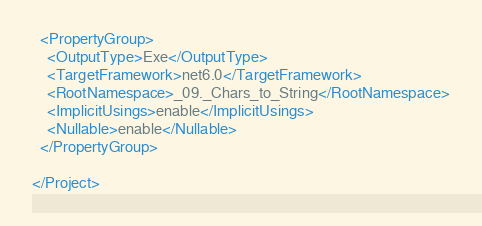<code> <loc_0><loc_0><loc_500><loc_500><_XML_>
  <PropertyGroup>
    <OutputType>Exe</OutputType>
    <TargetFramework>net6.0</TargetFramework>
    <RootNamespace>_09._Chars_to_String</RootNamespace>
    <ImplicitUsings>enable</ImplicitUsings>
    <Nullable>enable</Nullable>
  </PropertyGroup>

</Project>
</code> 